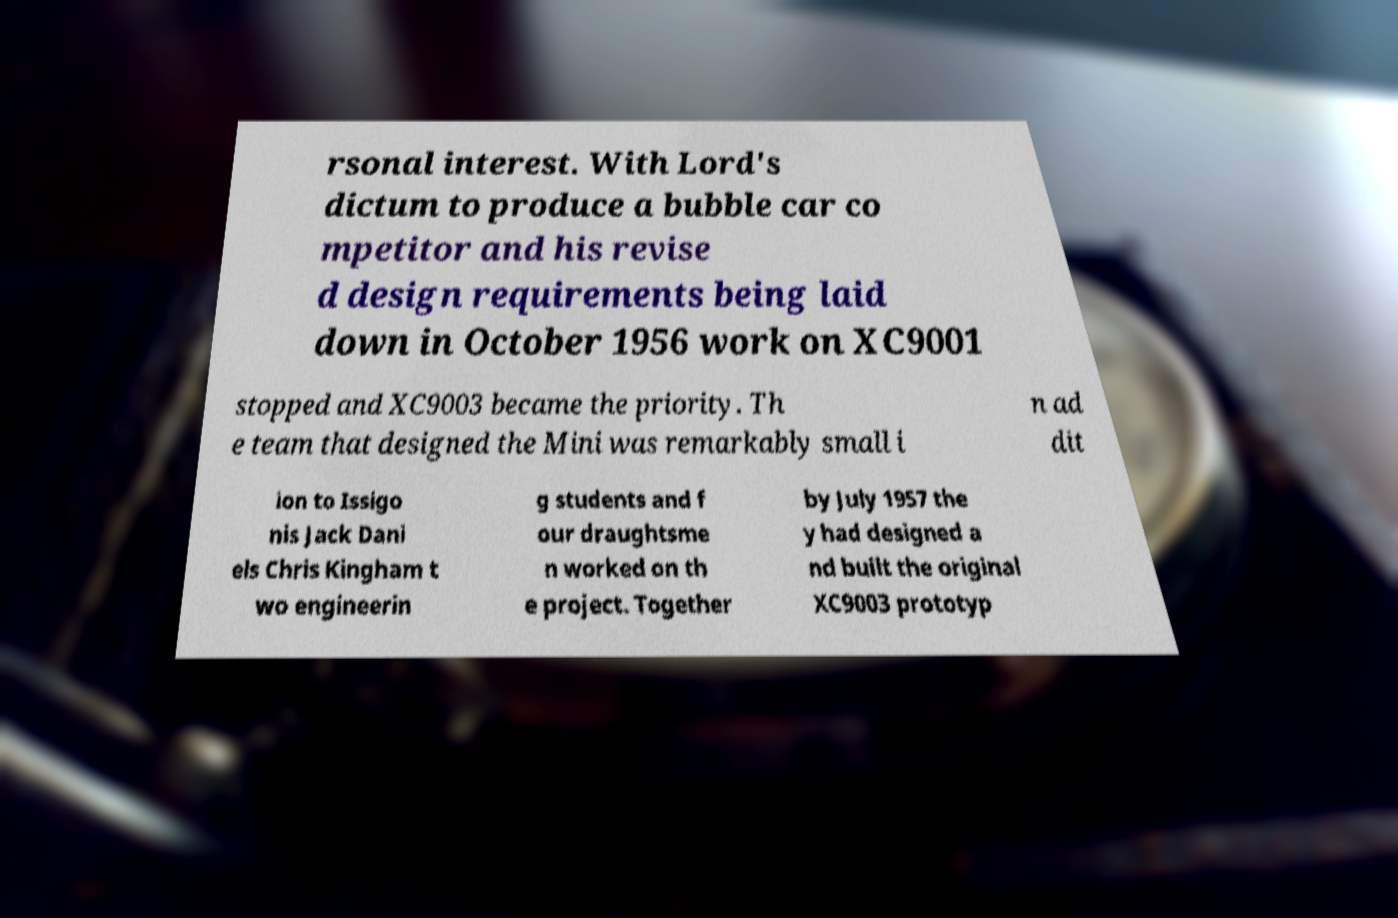There's text embedded in this image that I need extracted. Can you transcribe it verbatim? rsonal interest. With Lord's dictum to produce a bubble car co mpetitor and his revise d design requirements being laid down in October 1956 work on XC9001 stopped and XC9003 became the priority. Th e team that designed the Mini was remarkably small i n ad dit ion to Issigo nis Jack Dani els Chris Kingham t wo engineerin g students and f our draughtsme n worked on th e project. Together by July 1957 the y had designed a nd built the original XC9003 prototyp 